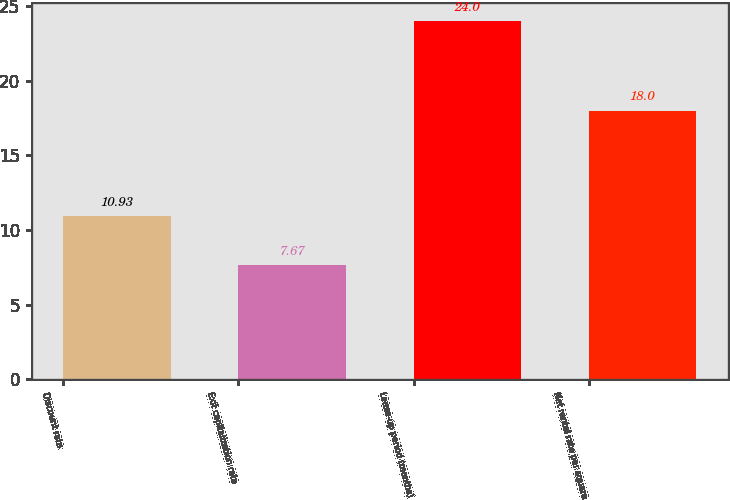<chart> <loc_0><loc_0><loc_500><loc_500><bar_chart><fcel>Discount rate<fcel>Exit capitalization rate<fcel>Lease-up period (months)<fcel>Net rental rate per square<nl><fcel>10.93<fcel>7.67<fcel>24<fcel>18<nl></chart> 